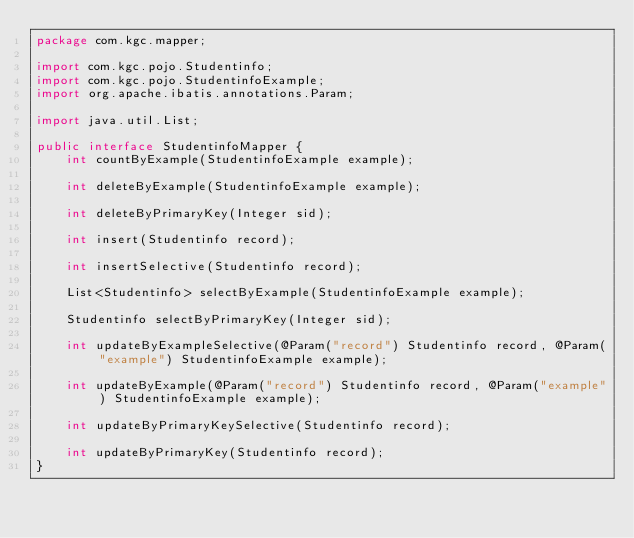<code> <loc_0><loc_0><loc_500><loc_500><_Java_>package com.kgc.mapper;

import com.kgc.pojo.Studentinfo;
import com.kgc.pojo.StudentinfoExample;
import org.apache.ibatis.annotations.Param;

import java.util.List;

public interface StudentinfoMapper {
    int countByExample(StudentinfoExample example);

    int deleteByExample(StudentinfoExample example);

    int deleteByPrimaryKey(Integer sid);

    int insert(Studentinfo record);

    int insertSelective(Studentinfo record);

    List<Studentinfo> selectByExample(StudentinfoExample example);

    Studentinfo selectByPrimaryKey(Integer sid);

    int updateByExampleSelective(@Param("record") Studentinfo record, @Param("example") StudentinfoExample example);

    int updateByExample(@Param("record") Studentinfo record, @Param("example") StudentinfoExample example);

    int updateByPrimaryKeySelective(Studentinfo record);

    int updateByPrimaryKey(Studentinfo record);
}</code> 